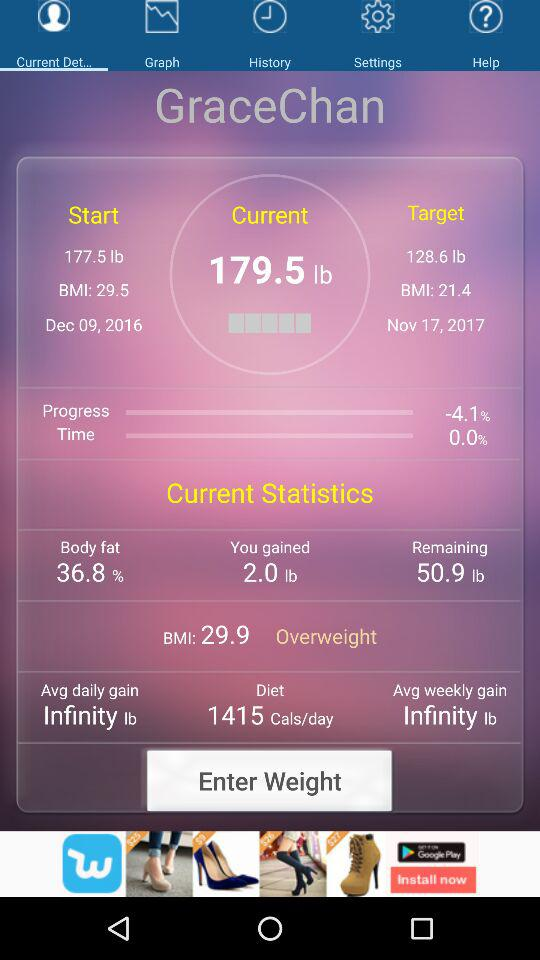What is the percentage of body fat? The percentage of body fat is 36.8. 